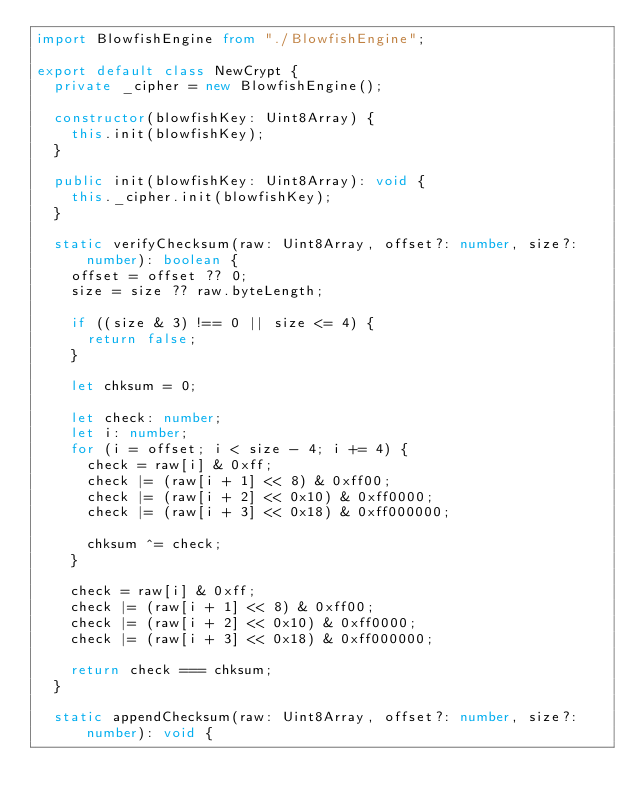<code> <loc_0><loc_0><loc_500><loc_500><_TypeScript_>import BlowfishEngine from "./BlowfishEngine";

export default class NewCrypt {
  private _cipher = new BlowfishEngine();

  constructor(blowfishKey: Uint8Array) {
    this.init(blowfishKey);
  }

  public init(blowfishKey: Uint8Array): void {
    this._cipher.init(blowfishKey);
  }

  static verifyChecksum(raw: Uint8Array, offset?: number, size?: number): boolean {
    offset = offset ?? 0;
    size = size ?? raw.byteLength;

    if ((size & 3) !== 0 || size <= 4) {
      return false;
    }

    let chksum = 0;

    let check: number;
    let i: number;
    for (i = offset; i < size - 4; i += 4) {
      check = raw[i] & 0xff;
      check |= (raw[i + 1] << 8) & 0xff00;
      check |= (raw[i + 2] << 0x10) & 0xff0000;
      check |= (raw[i + 3] << 0x18) & 0xff000000;

      chksum ^= check;
    }

    check = raw[i] & 0xff;
    check |= (raw[i + 1] << 8) & 0xff00;
    check |= (raw[i + 2] << 0x10) & 0xff0000;
    check |= (raw[i + 3] << 0x18) & 0xff000000;

    return check === chksum;
  }

  static appendChecksum(raw: Uint8Array, offset?: number, size?: number): void {</code> 